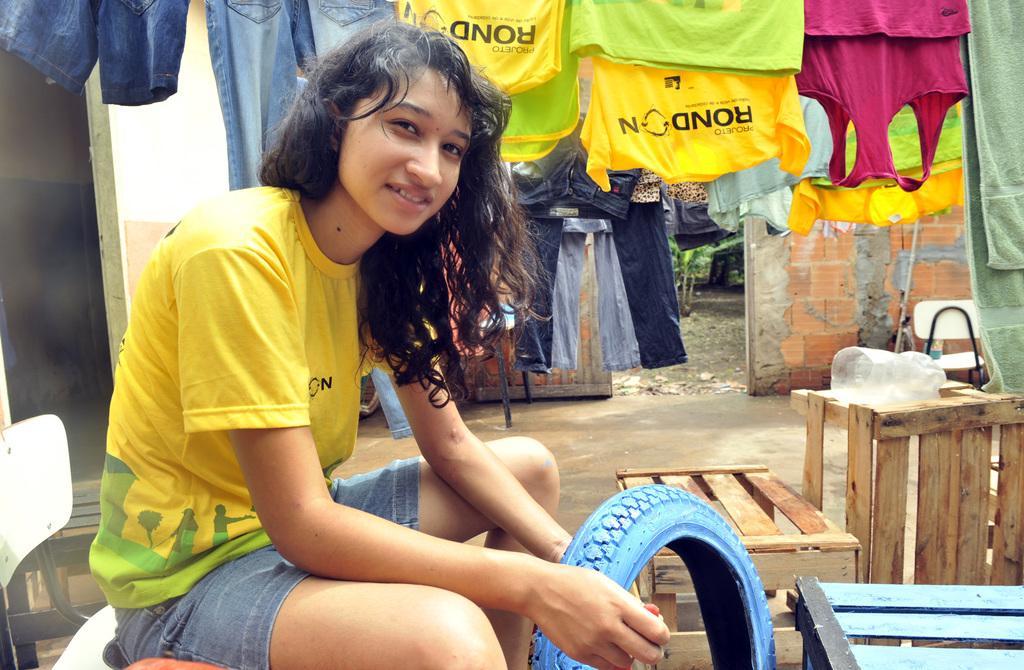Could you give a brief overview of what you see in this image? In the image there is a girl in yellow t-shirt and shorts holding a tire and beside her there are wooden boxes on the land, in the back there are clothes hanging to the rope and behind it there is a wall. 